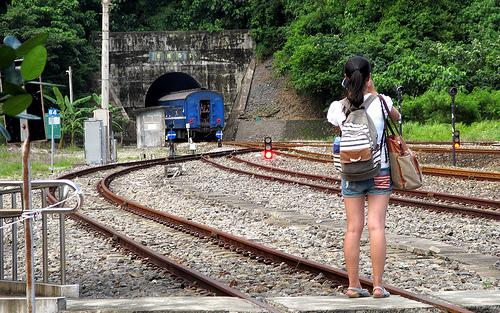Question: who is in the picture?
Choices:
A. A little boy.
B. A little girl.
C. A woman.
D. A man.
Answer with the letter. Answer: B Question: what is the girl doing?
Choices:
A. Reading a book.
B. Talking to a boy.
C. Eating candy.
D. Watching a train.
Answer with the letter. Answer: D Question: what color is the train?
Choices:
A. Red.
B. Blue.
C. Black.
D. White.
Answer with the letter. Answer: B Question: where was this picture taken?
Choices:
A. A beach.
B. A house.
C. A field.
D. A train stop.
Answer with the letter. Answer: D Question: how is the weather?
Choices:
A. It is rainy.
B. It is snowing.
C. It is windy.
D. It is clear.
Answer with the letter. Answer: D Question: where is the train?
Choices:
A. On the train tracks.
B. In the city.
C. Inside a building.
D. Going in the mountains.
Answer with the letter. Answer: A 